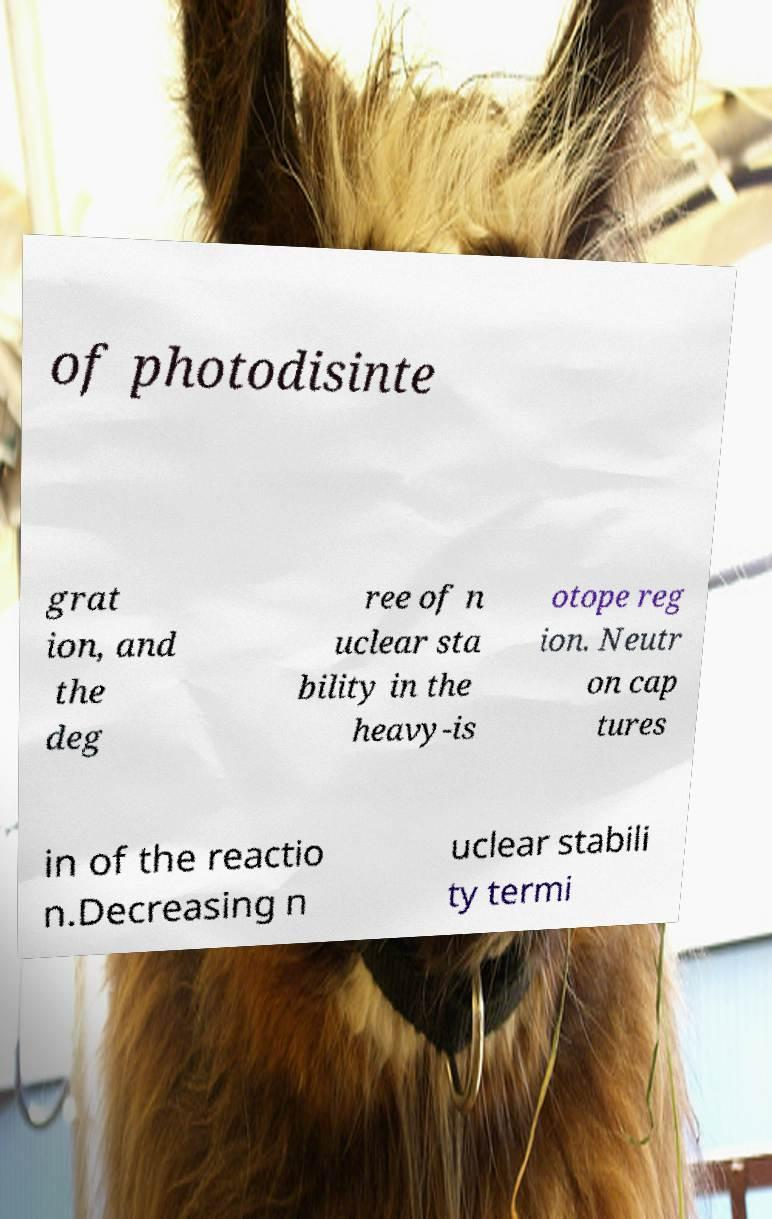What messages or text are displayed in this image? I need them in a readable, typed format. of photodisinte grat ion, and the deg ree of n uclear sta bility in the heavy-is otope reg ion. Neutr on cap tures in of the reactio n.Decreasing n uclear stabili ty termi 